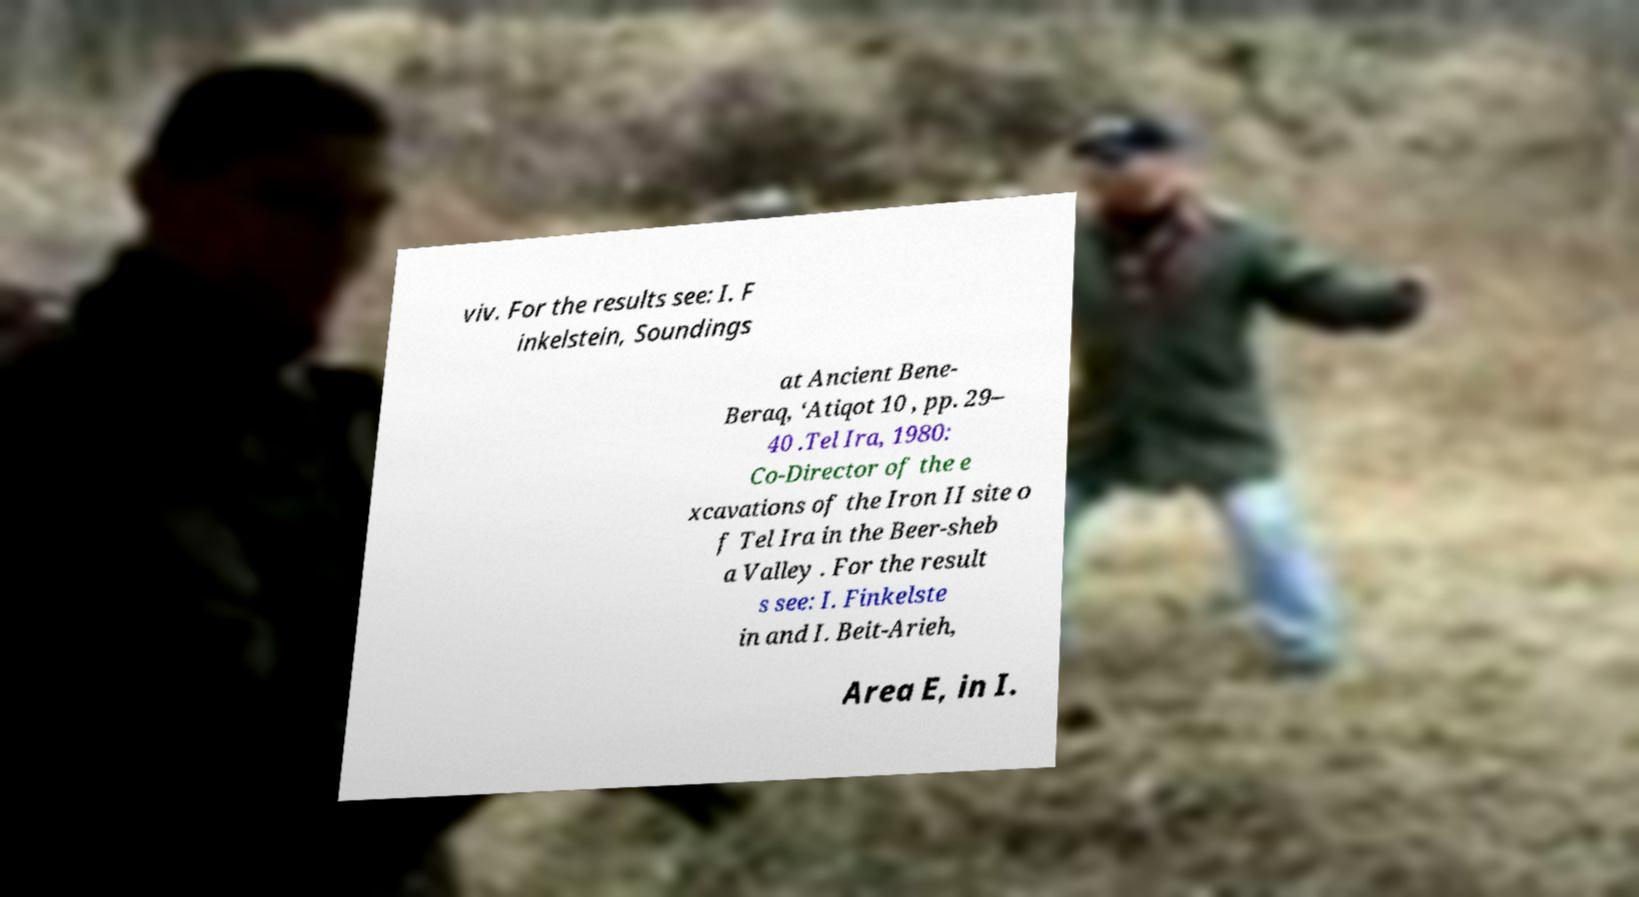I need the written content from this picture converted into text. Can you do that? viv. For the results see: I. F inkelstein, Soundings at Ancient Bene- Beraq, ‘Atiqot 10 , pp. 29– 40 .Tel Ira, 1980: Co-Director of the e xcavations of the Iron II site o f Tel Ira in the Beer-sheb a Valley . For the result s see: I. Finkelste in and I. Beit-Arieh, Area E, in I. 